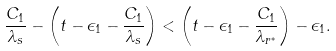Convert formula to latex. <formula><loc_0><loc_0><loc_500><loc_500>\frac { C _ { 1 } } { \lambda _ { s } } - \left ( t - \epsilon _ { 1 } - \frac { C _ { 1 } } { \lambda _ { s } } \right ) < \left ( t - \epsilon _ { 1 } - \frac { C _ { 1 } } { \lambda _ { r ^ { * } } } \right ) - \epsilon _ { 1 } .</formula> 